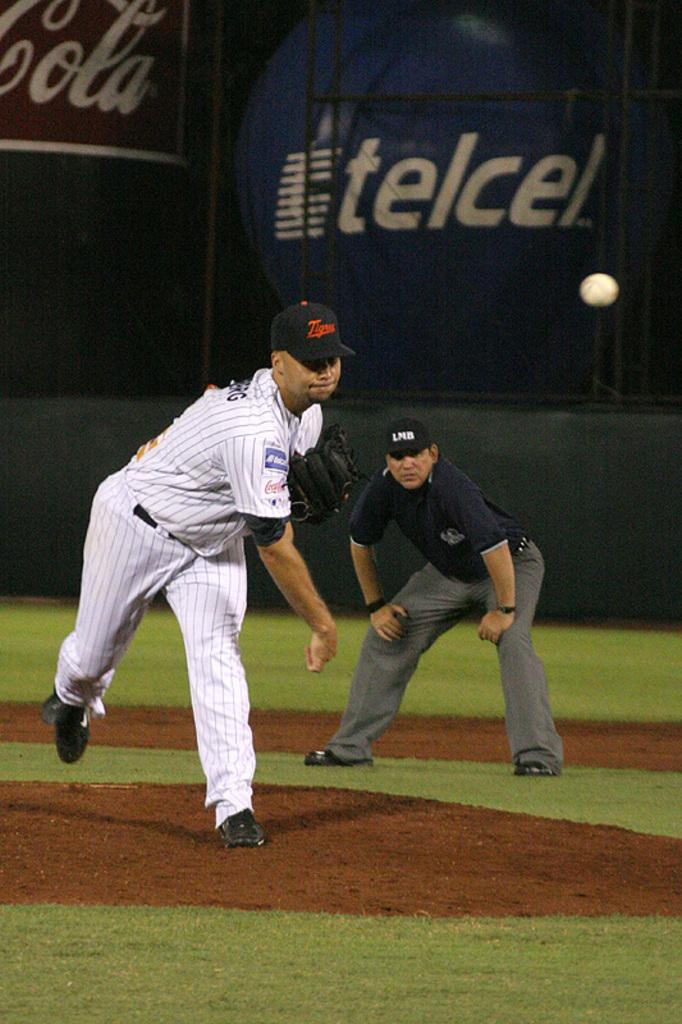<image>
Create a compact narrative representing the image presented. A baseball player throws a pitch while an add for TelCel plays behind him. 